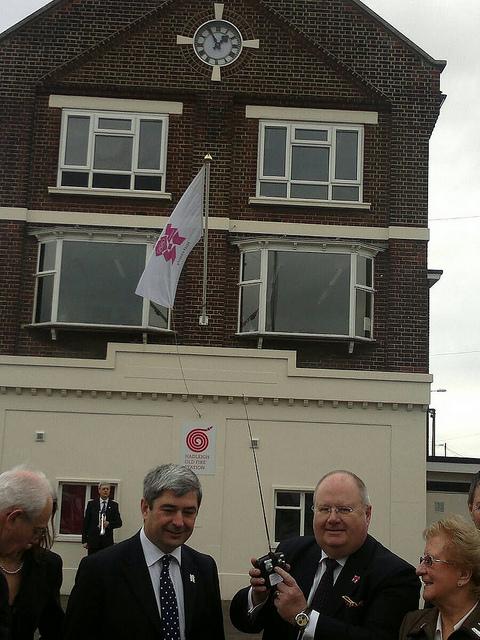How many people are in the photo?
Keep it brief. 5. How many flags are there?
Quick response, please. 1. How many windows are visible?
Concise answer only. 4. How many windows are in this photo?
Give a very brief answer. 6. How many men are bald in this picture?
Be succinct. 1. 